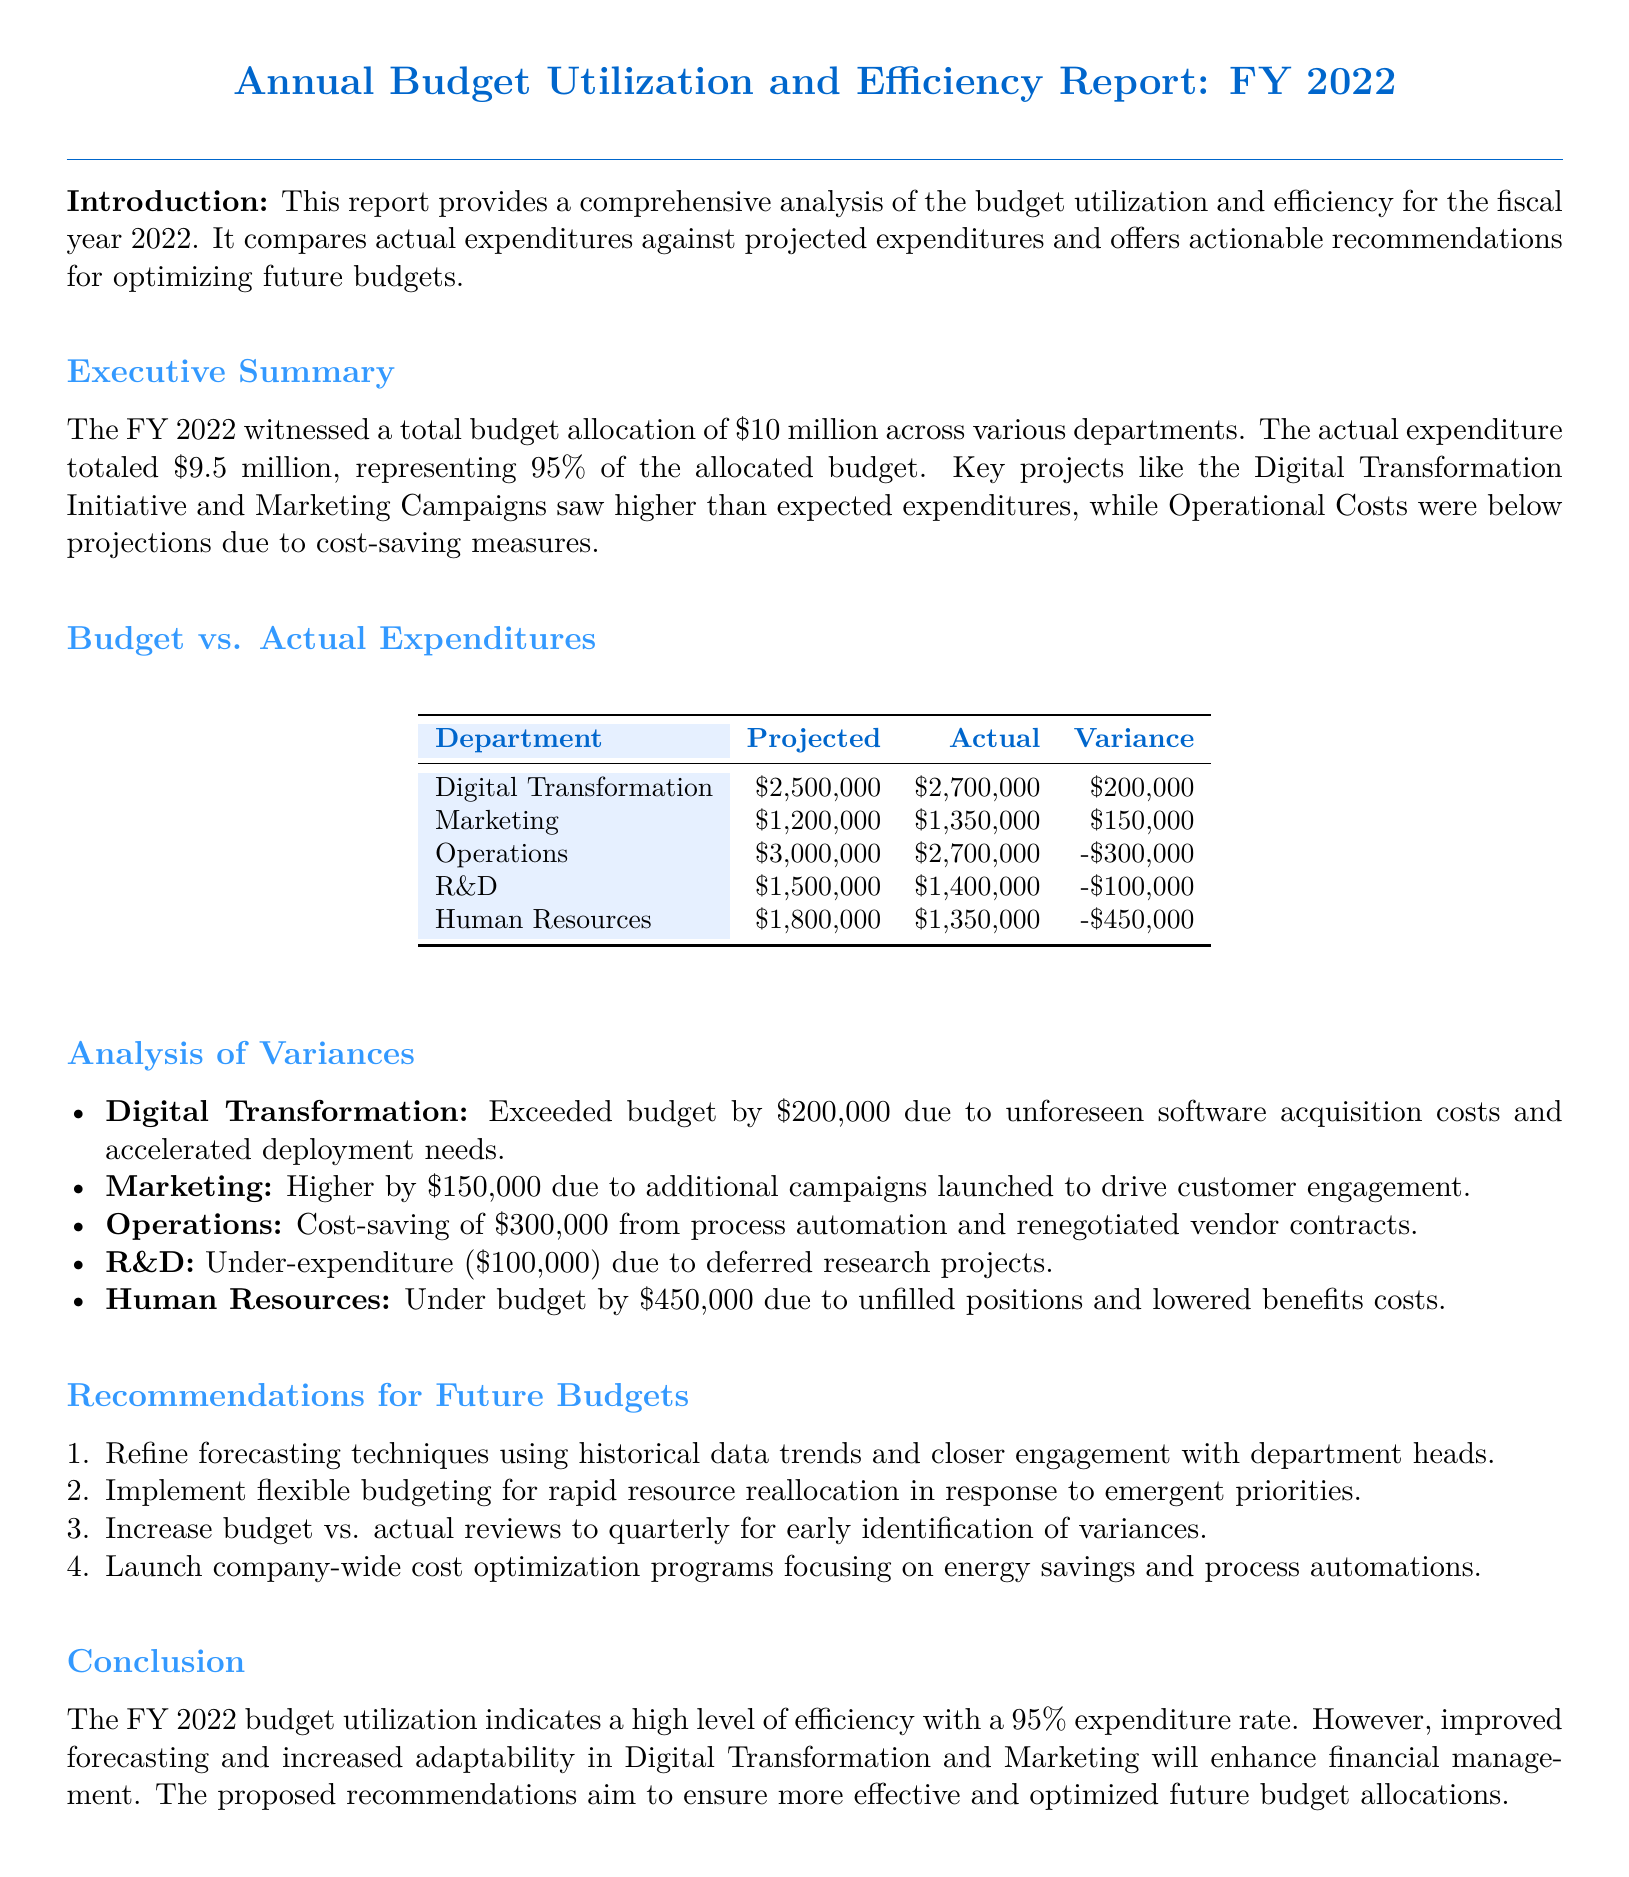What was the total budget allocation for FY 2022? The total budget allocation for FY 2022 is mentioned at the beginning of the document as $10 million.
Answer: $10 million How much was the actual expenditure for FY 2022? The actual expenditure is provided in the Executive Summary section as totaling $9.5 million.
Answer: $9.5 million What department had the highest variance in budget utilization? The variance analysis shows that Digital Transformation had the highest positive variance of $200,000.
Answer: Digital Transformation What is the total under-expenditure for the Human Resources department? The analysis lists Human Resources's under-expenditure as $450,000.
Answer: $450,000 What recommendation is made regarding budget reviews? The recommendations section suggests increasing budget vs. actual reviews to quarterly for better monitoring.
Answer: quarterly What was the variance for the Marketing department? The table under "Budget vs. Actual Expenditures" lists the variance for Marketing as $150,000.
Answer: $150,000 Which project caused unforeseen software acquisition costs? The report specifies that the Digital Transformation Initiative exceeded its budget due to unforeseen costs.
Answer: Digital Transformation Initiative What fiscal year does the report cover? The title of the document states it relates to the fiscal year 2022.
Answer: FY 2022 What was the total expenditure percentage of the allocated budget? According to the Executive Summary, the total expenditure percentage of the allocated budget was 95%.
Answer: 95% 